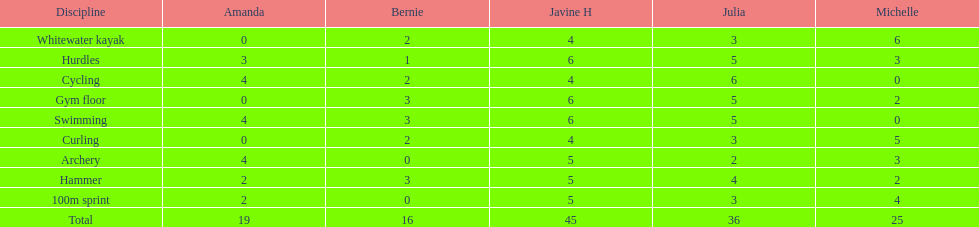Who earned the most total points? Javine H. 